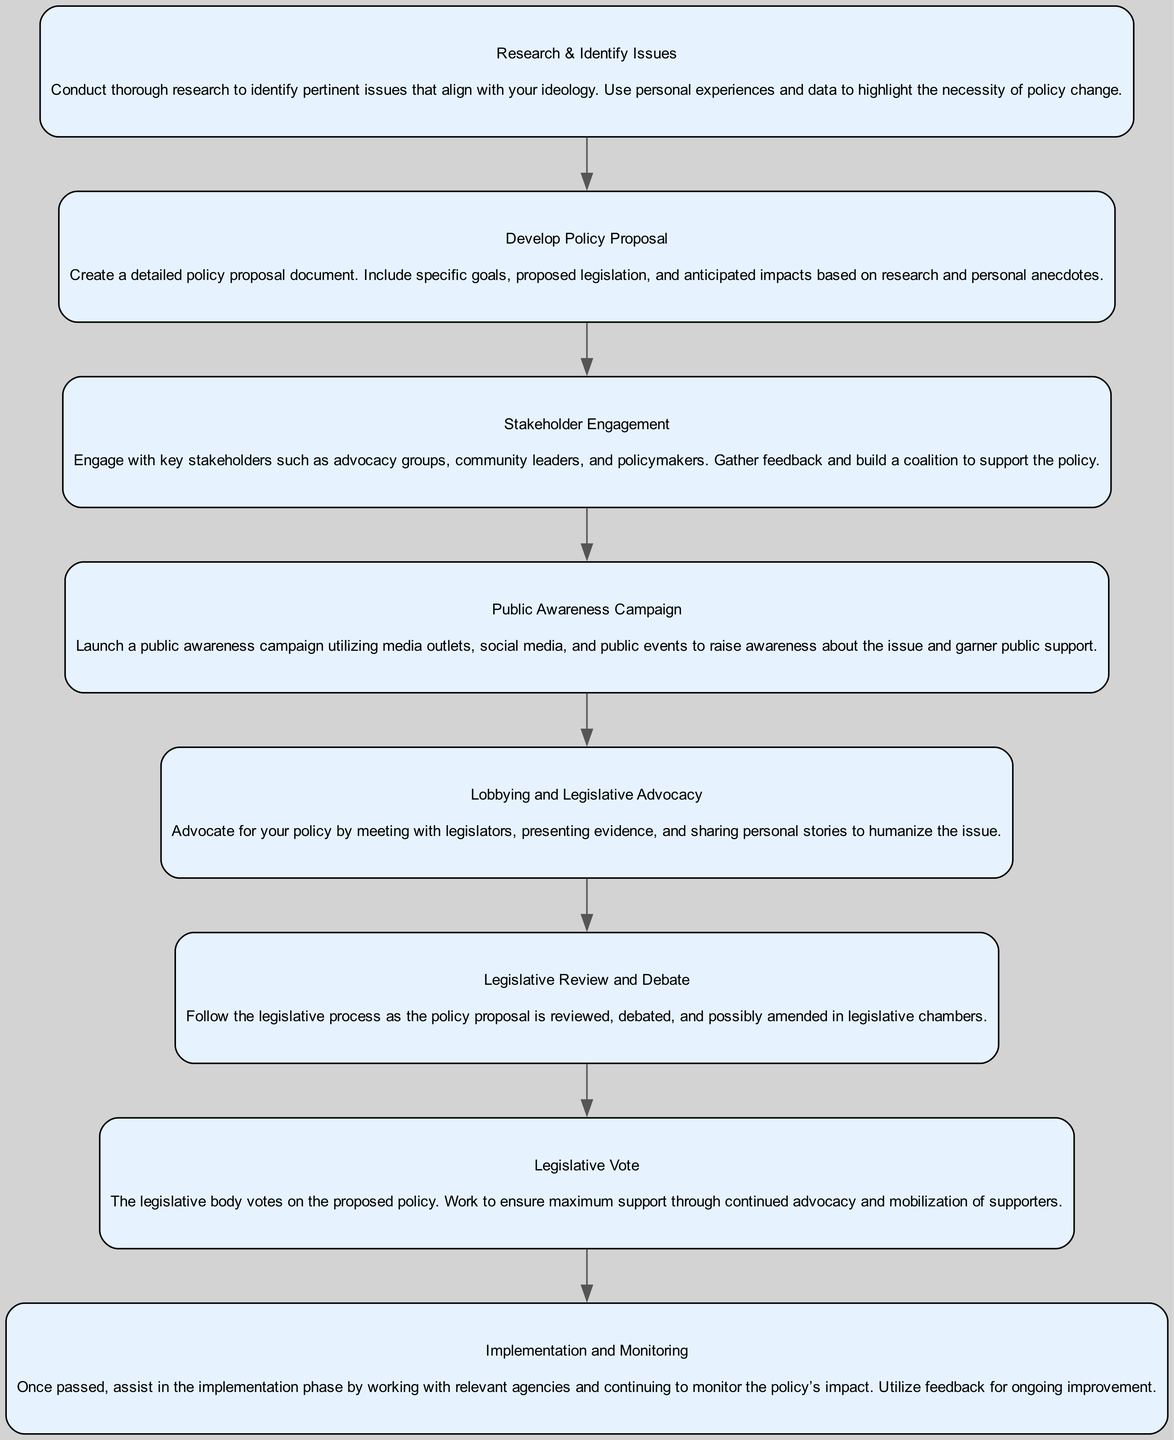What is the first step in the policy advocacy process? The first step in the diagram is "Research & Identify Issues," which is where thorough research is conducted to identify relevant issues.
Answer: Research & Identify Issues How many dependencies does "Legislative Vote" have? "Legislative Vote" has one dependency, which is "Legislative Review and Debate." This can be confirmed by checking the connections in the diagram.
Answer: 1 What follows after the "Public Awareness Campaign" in the process? After the "Public Awareness Campaign," the next step is "Lobbying and Legislative Advocacy," indicating the flow of the process.
Answer: Lobbying and Legislative Advocacy Which element directly engages stakeholders? "Stakeholder Engagement" is the element that specifically focuses on engaging key stakeholders such as advocacy groups and community leaders.
Answer: Stakeholder Engagement In the process, what is created after "Develop Policy Proposal"? Following "Develop Policy Proposal," the next step is "Stakeholder Engagement," indicating that the proposal leads to the involvement of stakeholders.
Answer: Stakeholder Engagement What is the last step in the advocacy process? The last step is "Implementation and Monitoring," which is the final phase where the policy is implemented and its impact is monitored.
Answer: Implementation and Monitoring How many total elements are in the diagram? There are eight elements in the diagram, as each step in the process is outlined clearly, making it easy to count.
Answer: 8 What type of campaign is launched after engaging stakeholders? A "Public Awareness Campaign" is launched after engaging with stakeholders to raise awareness about the policy issue.
Answer: Public Awareness Campaign 